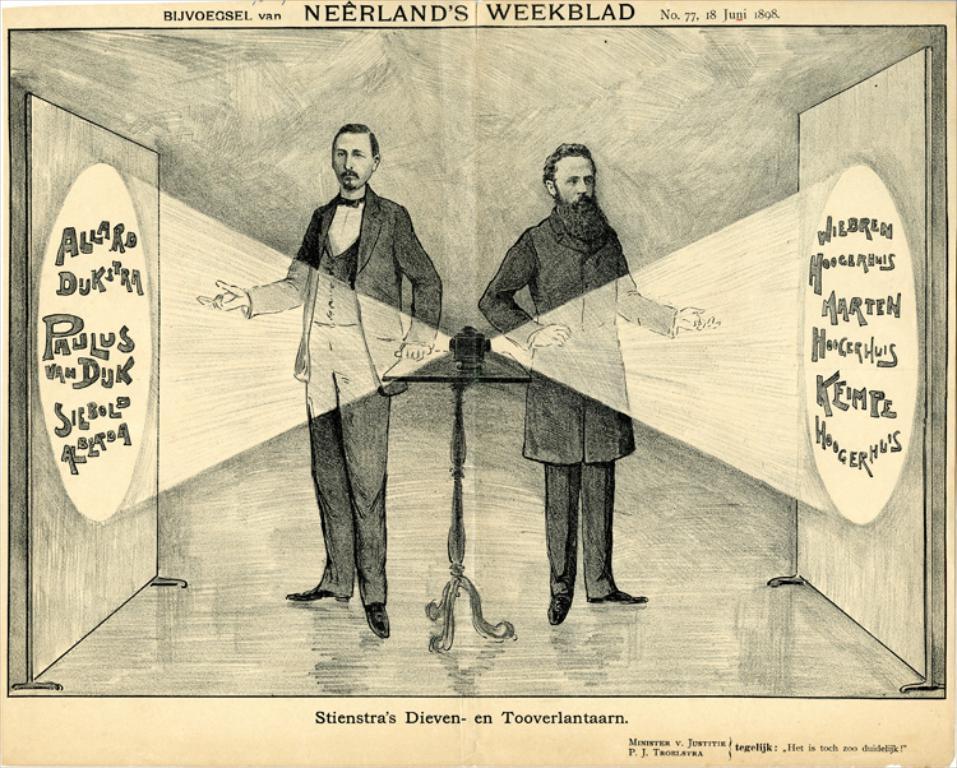Describe this image in one or two sentences. This is a drawing of two persons standing. Also there is a stand on that there is a machine. And there are two boards on the sides. And something is written on the boards. At the top and bottom something is written on the image. 